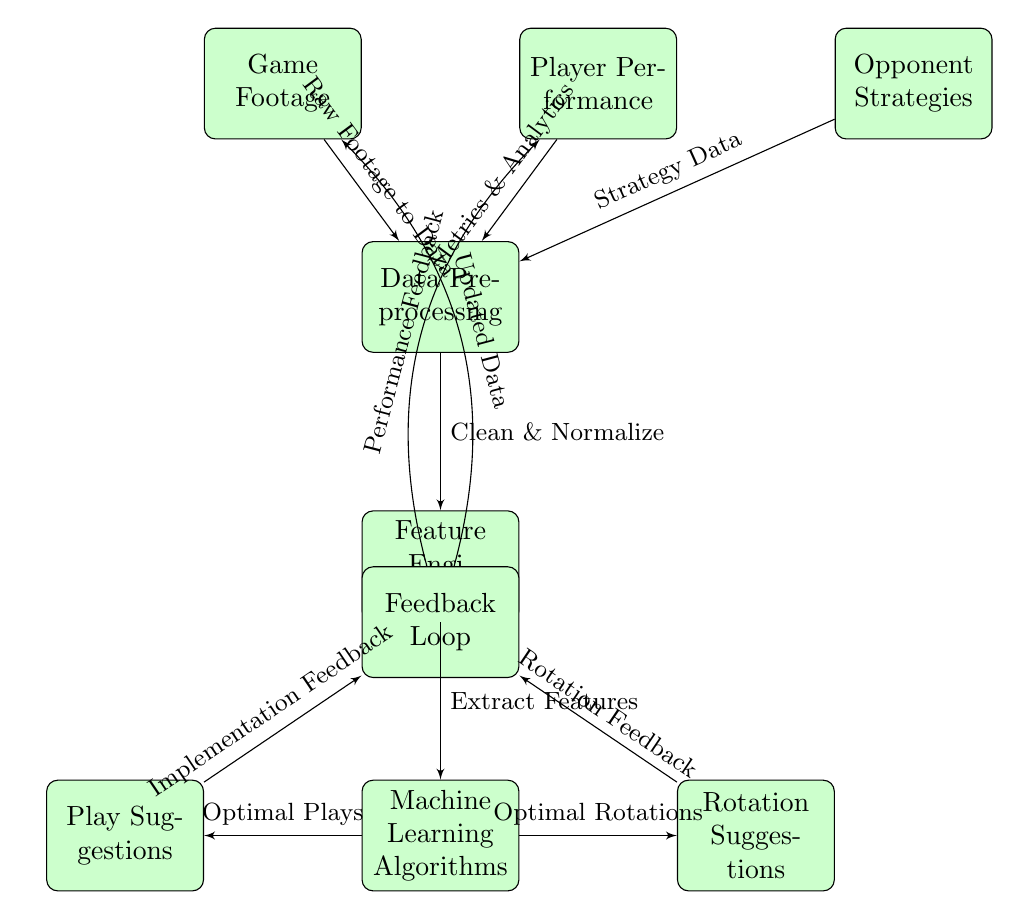What is the first node in the diagram? The first node in the diagram is labeled "Game Footage," which is positioned on the leftmost part of the diagram.
Answer: Game Footage How many nodes are present in the diagram? There are a total of eight nodes in the diagram. Counting each distinct block, we have Game Footage, Player Performance, Opponent Strategies, Data Preprocessing, Feature Engineering, Machine Learning Algorithms, Play Suggestions, and Rotation Suggestions.
Answer: 8 What type of data is connected from Player Performance to Data Preprocessing? The data connected from Player Performance to Data Preprocessing is described as "Metrics & Analytics." This indicates the nature of the information that flows from the Player Performance node into the preprocessing stage.
Answer: Metrics & Analytics Which block comes directly after Data Preprocessing? The block that comes directly after Data Preprocessing in the flow is "Feature Engineering," which is shown below Data Preprocessing in the diagram.
Answer: Feature Engineering What are the outputs of Machine Learning Algorithms? The outputs of the Machine Learning Algorithms are "Optimal Plays" and "Optimal Rotations," both of which are represented as outputs stemming from the algorithms block.
Answer: Optimal Plays, Optimal Rotations What is the purpose of the Feedback Loop? The purpose of the Feedback Loop is to integrate both "Updated Data" from Game Footage and "Performance Feedback" from Player Performance to inform future processing and refine the model's suggestions.
Answer: Integrate feedback How do Play Suggestions connect to the Feedback Loop? The connection from Play Suggestions to the Feedback Loop illustrates that implementation feedback from the suggested plays will feed back into the loop to enhance the overall model. This pathway indicates the system's iterative nature.
Answer: Implementation Feedback How does the Data Preprocessing node interact with the other three data sources? Data Preprocessing interacts with the other three data sources—Game Footage, Player Performance, and Opponent Strategies—by receiving raw footage, metrics & analytics, and strategy data. This is reflected in the arrows leading into Data Preprocessing.
Answer: Raw footage, metrics & analytics, strategy data What do the arrows represent in this diagram? The arrows in the diagram represent the flow of information and data processing between the different blocks, illustrating how inputs are transformed into outputs at each stage.
Answer: Flow of information 